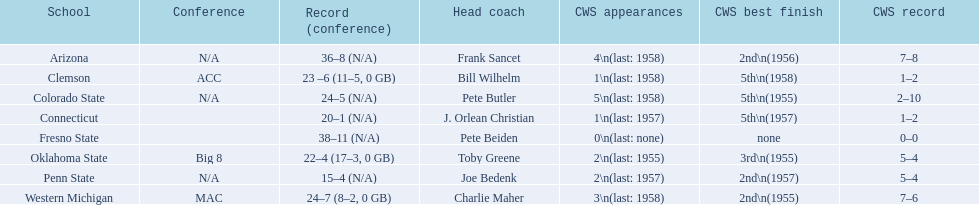How many cws appearances does clemson have? 1\n(last: 1958). How many cws appearances does western michigan have? 3\n(last: 1958). Which of these schools has more cws appearances? Western Michigan. 